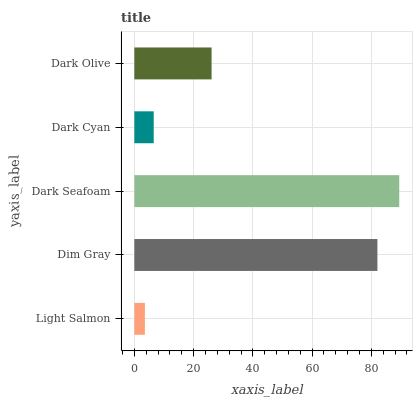Is Light Salmon the minimum?
Answer yes or no. Yes. Is Dark Seafoam the maximum?
Answer yes or no. Yes. Is Dim Gray the minimum?
Answer yes or no. No. Is Dim Gray the maximum?
Answer yes or no. No. Is Dim Gray greater than Light Salmon?
Answer yes or no. Yes. Is Light Salmon less than Dim Gray?
Answer yes or no. Yes. Is Light Salmon greater than Dim Gray?
Answer yes or no. No. Is Dim Gray less than Light Salmon?
Answer yes or no. No. Is Dark Olive the high median?
Answer yes or no. Yes. Is Dark Olive the low median?
Answer yes or no. Yes. Is Dark Cyan the high median?
Answer yes or no. No. Is Light Salmon the low median?
Answer yes or no. No. 